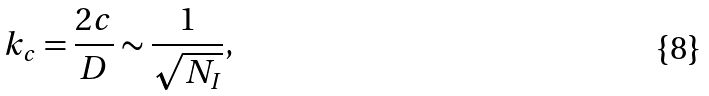<formula> <loc_0><loc_0><loc_500><loc_500>k _ { c } = \frac { 2 c } { D } \sim \frac { 1 } { \sqrt { N _ { I } } } ,</formula> 